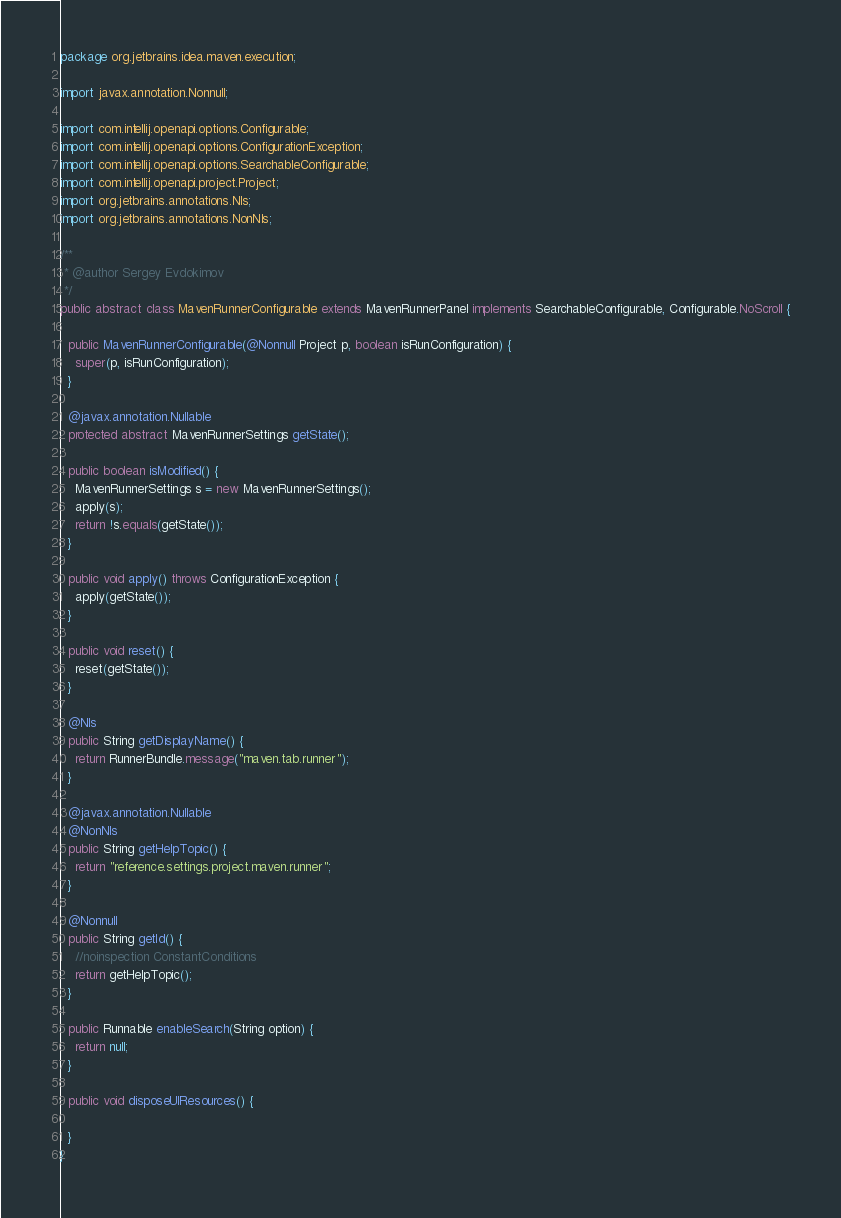<code> <loc_0><loc_0><loc_500><loc_500><_Java_>package org.jetbrains.idea.maven.execution;

import javax.annotation.Nonnull;

import com.intellij.openapi.options.Configurable;
import com.intellij.openapi.options.ConfigurationException;
import com.intellij.openapi.options.SearchableConfigurable;
import com.intellij.openapi.project.Project;
import org.jetbrains.annotations.Nls;
import org.jetbrains.annotations.NonNls;

/**
 * @author Sergey Evdokimov
 */
public abstract class MavenRunnerConfigurable extends MavenRunnerPanel implements SearchableConfigurable, Configurable.NoScroll {

  public MavenRunnerConfigurable(@Nonnull Project p, boolean isRunConfiguration) {
    super(p, isRunConfiguration);
  }

  @javax.annotation.Nullable
  protected abstract MavenRunnerSettings getState();

  public boolean isModified() {
    MavenRunnerSettings s = new MavenRunnerSettings();
    apply(s);
    return !s.equals(getState());
  }

  public void apply() throws ConfigurationException {
    apply(getState());
  }

  public void reset() {
    reset(getState());
  }

  @Nls
  public String getDisplayName() {
    return RunnerBundle.message("maven.tab.runner");
  }

  @javax.annotation.Nullable
  @NonNls
  public String getHelpTopic() {
    return "reference.settings.project.maven.runner";
  }

  @Nonnull
  public String getId() {
    //noinspection ConstantConditions
    return getHelpTopic();
  }

  public Runnable enableSearch(String option) {
    return null;
  }

  public void disposeUIResources() {

  }
}
</code> 